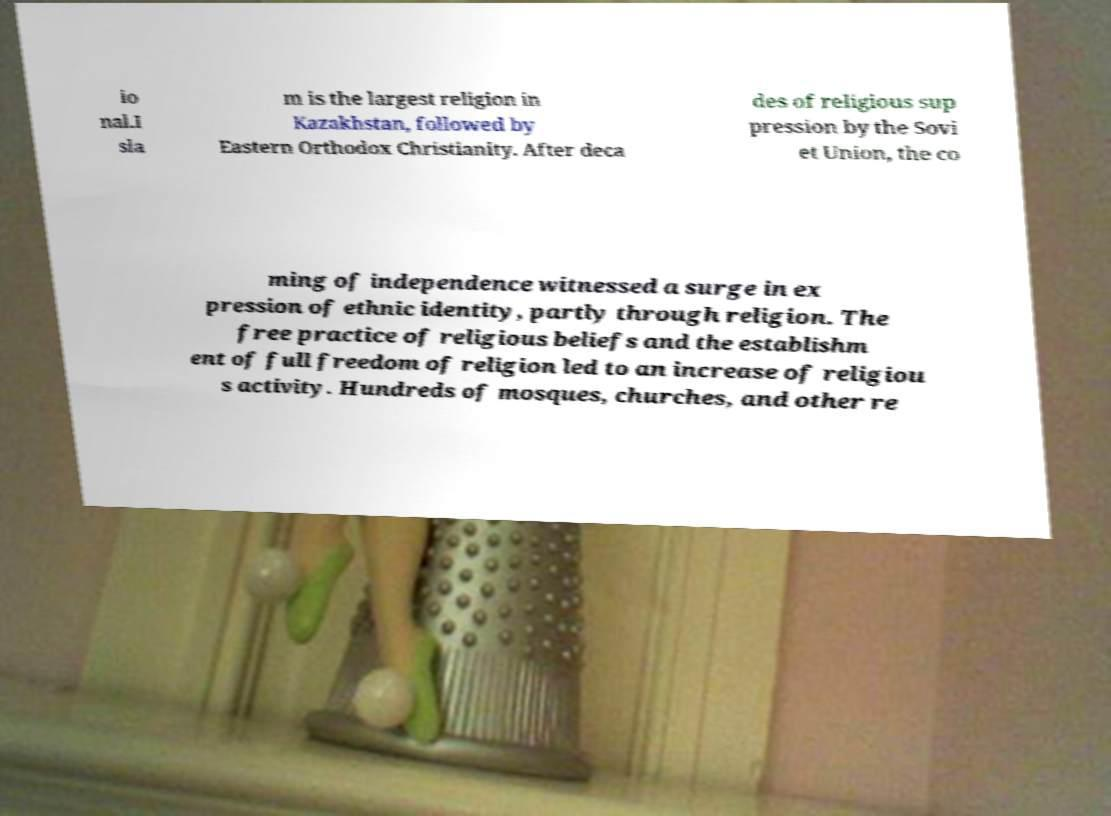Could you assist in decoding the text presented in this image and type it out clearly? io nal.I sla m is the largest religion in Kazakhstan, followed by Eastern Orthodox Christianity. After deca des of religious sup pression by the Sovi et Union, the co ming of independence witnessed a surge in ex pression of ethnic identity, partly through religion. The free practice of religious beliefs and the establishm ent of full freedom of religion led to an increase of religiou s activity. Hundreds of mosques, churches, and other re 